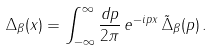<formula> <loc_0><loc_0><loc_500><loc_500>\Delta _ { \beta } ( x ) = \int _ { - \infty } ^ { \infty } { \frac { d p } { 2 \pi } } \, e ^ { - i p x } \, \tilde { \Delta } _ { \beta } ( p ) \, .</formula> 